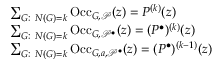Convert formula to latex. <formula><loc_0><loc_0><loc_500><loc_500>\begin{array} { r l } & { \sum _ { G \colon \ N ( G ) = k } O c c _ { G , \mathcal { P } } ( z ) = P ^ { ( k ) } ( z ) } \\ & { \sum _ { G \colon \ N ( G ) = k } O c c _ { G , \mathcal { P } ^ { \bullet } } ( z ) = ( P ^ { \bullet } ) ^ { ( k ) } ( z ) } \\ & { \sum _ { G \colon \ N ( G ) = k } O c c _ { G , a , \mathcal { P } ^ { \bullet } } ( z ) = ( P ^ { \bullet } ) ^ { ( k - 1 ) } ( z ) } \end{array}</formula> 